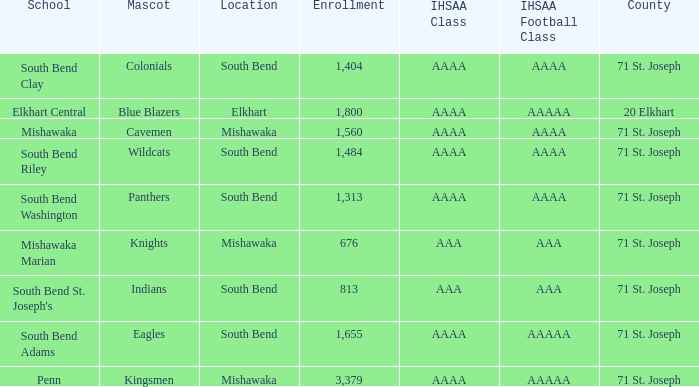What IHSAA Football Class has 20 elkhart as the county? AAAAA. 